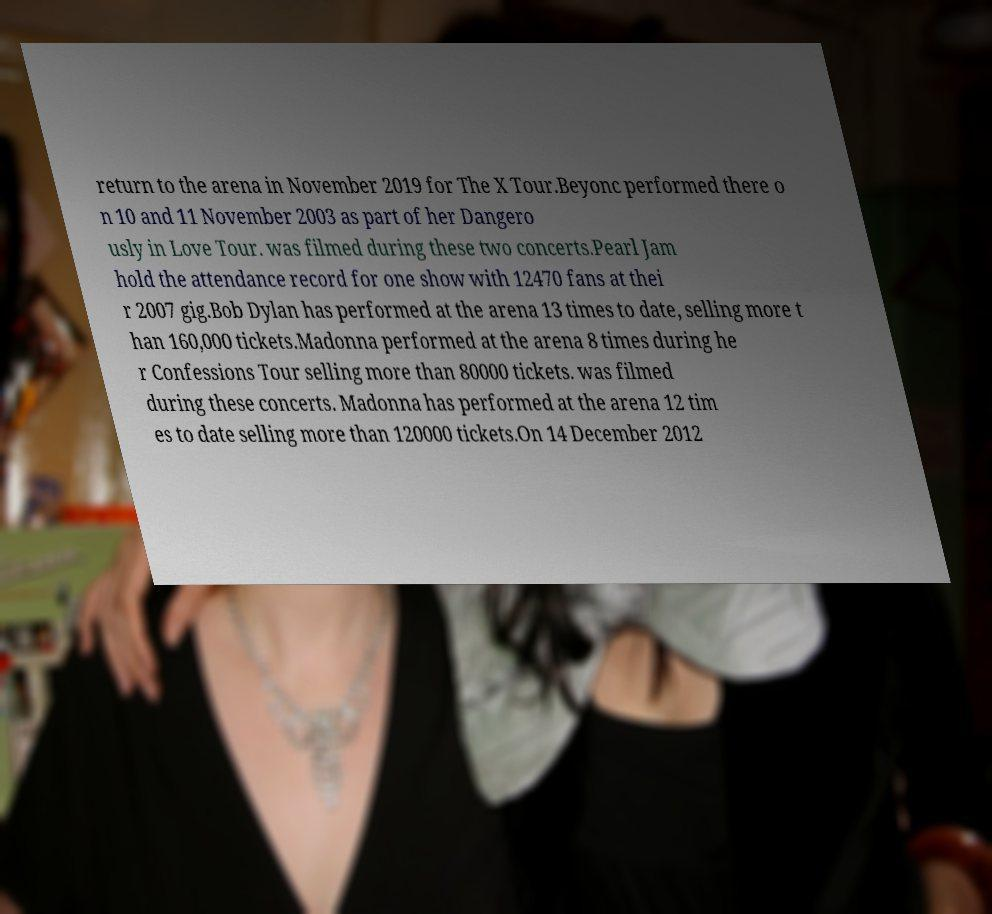Can you read and provide the text displayed in the image?This photo seems to have some interesting text. Can you extract and type it out for me? return to the arena in November 2019 for The X Tour.Beyonc performed there o n 10 and 11 November 2003 as part of her Dangero usly in Love Tour. was filmed during these two concerts.Pearl Jam hold the attendance record for one show with 12470 fans at thei r 2007 gig.Bob Dylan has performed at the arena 13 times to date, selling more t han 160,000 tickets.Madonna performed at the arena 8 times during he r Confessions Tour selling more than 80000 tickets. was filmed during these concerts. Madonna has performed at the arena 12 tim es to date selling more than 120000 tickets.On 14 December 2012 